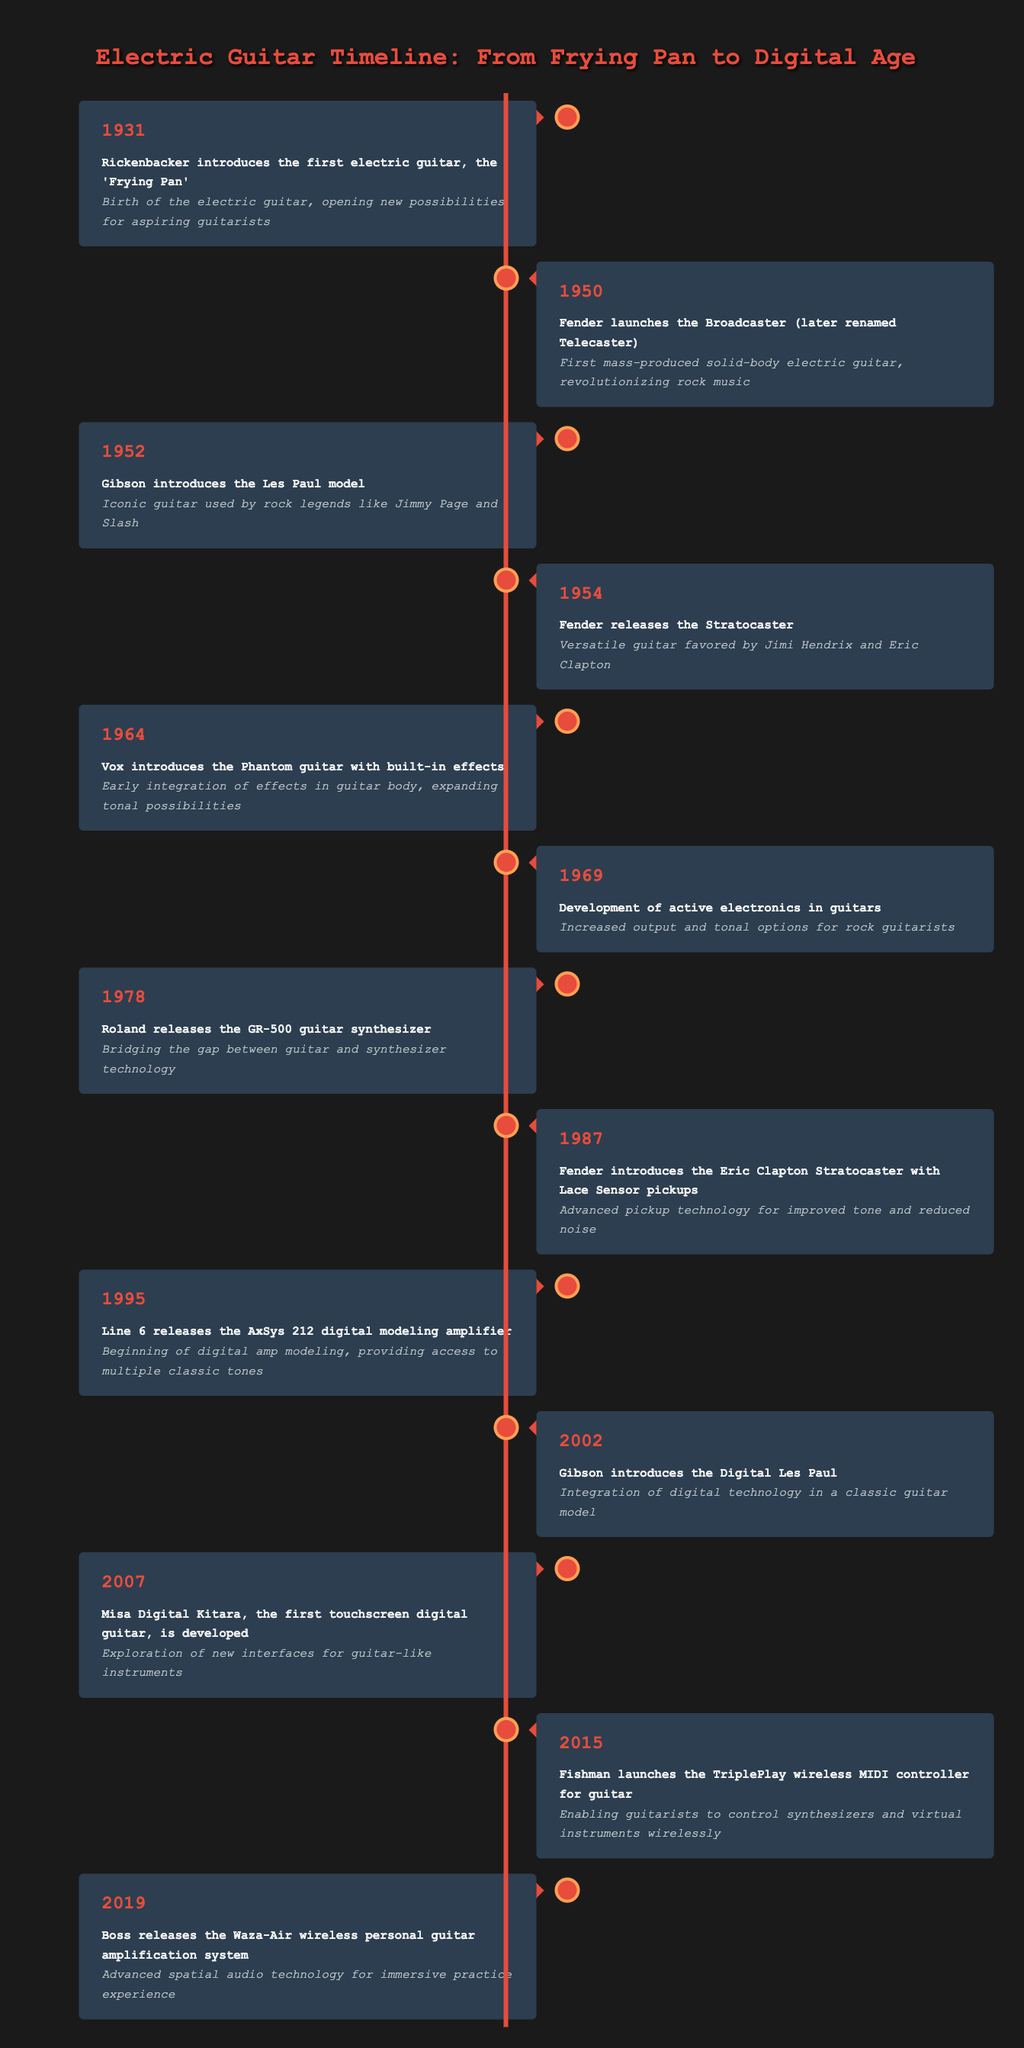What year was the first electric guitar introduced? According to the table, Rickenbacker introduced the first electric guitar, the 'Frying Pan', in the year 1931.
Answer: 1931 What significant event in electric guitar history occurred in 1954? In 1954, Fender released the Stratocaster, which is noted as a versatile guitar favored by famous guitarists like Jimi Hendrix and Eric Clapton.
Answer: Fender released the Stratocaster Which guitar model is associated with rock legends like Jimmy Page and Slash? The table mentions that the Gibson Les Paul model, introduced in 1952, is the iconic guitar associated with rock legends like Jimmy Page and Slash.
Answer: Gibson Les Paul model How many years passed between the introduction of the first electric guitar and the release of the Digital Les Paul? The first electric guitar was introduced in 1931, and the Digital Les Paul was introduced in 2002. The difference in years is 2002 - 1931 = 71 years.
Answer: 71 years Did Vox introduce a guitar with built-in effects before or after 1970? The table states that Vox introduced the Phantom guitar with built-in effects in 1964, which is before 1970.
Answer: Before What technological development in guitars occurred in 1969? According to the table, the development of active electronics in guitars occurred in 1969, which increased output and tonal options for rock guitarists.
Answer: Development of active electronics What is the significance of the Fishman TriplePlay launched in 2015? The Fishman TriplePlay launched in 2015 is significant because it enabled guitarists to control synthesizers and virtual instruments wirelessly, showcasing an evolution in guitar technology.
Answer: Enabled wireless control of synthesizers How many major guitar model releases are listed between the years 1950 and 1969? The years from 1950 to 1969 include five major releases: 1950 - Broadcaster, 1952 - Les Paul, 1954 - Stratocaster, 1964 - Phantom guitar, and 1969 - active electronics. Therefore, there are 5 releases.
Answer: 5 releases In what year did Gibson first integrate digital technology in a guitar? The table indicates that Gibson introduced the Digital Les Paul in 2002, marking the first integration of digital technology in a classic guitar model.
Answer: 2002 